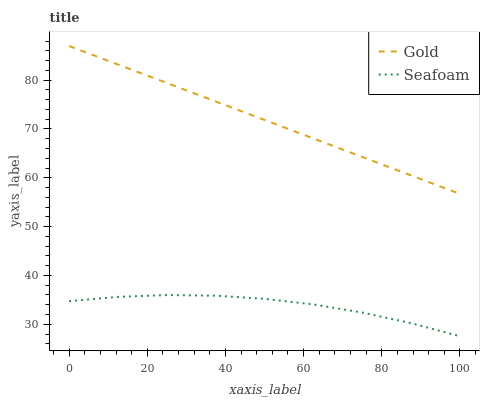Does Seafoam have the minimum area under the curve?
Answer yes or no. Yes. Does Gold have the maximum area under the curve?
Answer yes or no. Yes. Does Gold have the minimum area under the curve?
Answer yes or no. No. Is Gold the smoothest?
Answer yes or no. Yes. Is Seafoam the roughest?
Answer yes or no. Yes. Is Gold the roughest?
Answer yes or no. No. Does Seafoam have the lowest value?
Answer yes or no. Yes. Does Gold have the lowest value?
Answer yes or no. No. Does Gold have the highest value?
Answer yes or no. Yes. Is Seafoam less than Gold?
Answer yes or no. Yes. Is Gold greater than Seafoam?
Answer yes or no. Yes. Does Seafoam intersect Gold?
Answer yes or no. No. 